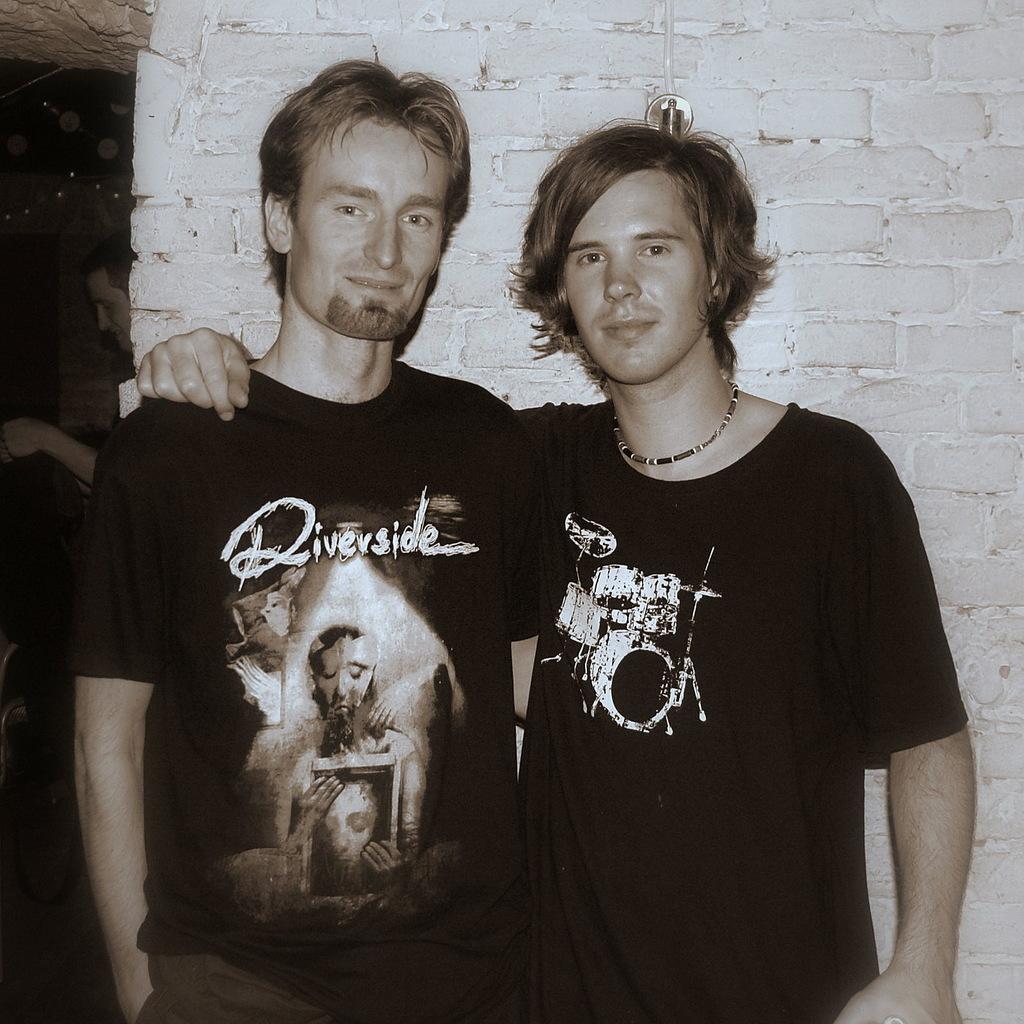Can you describe this image briefly? In this image I can see in the middle two men are standing, they are wearing the t-shirts, at the back side there is the wall. This image is in black and white color. 